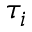Convert formula to latex. <formula><loc_0><loc_0><loc_500><loc_500>\tau _ { i }</formula> 